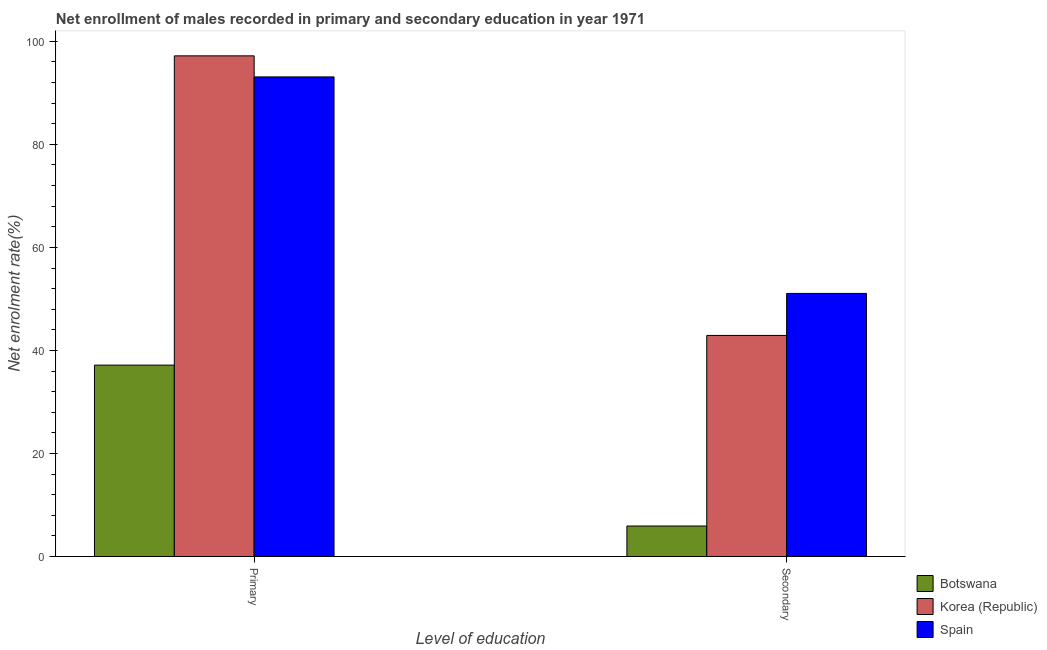How many different coloured bars are there?
Your answer should be compact. 3. How many groups of bars are there?
Your response must be concise. 2. Are the number of bars per tick equal to the number of legend labels?
Your answer should be very brief. Yes. Are the number of bars on each tick of the X-axis equal?
Keep it short and to the point. Yes. How many bars are there on the 1st tick from the left?
Your response must be concise. 3. What is the label of the 1st group of bars from the left?
Your response must be concise. Primary. What is the enrollment rate in primary education in Korea (Republic)?
Keep it short and to the point. 97.18. Across all countries, what is the maximum enrollment rate in primary education?
Your answer should be compact. 97.18. Across all countries, what is the minimum enrollment rate in primary education?
Your answer should be very brief. 37.15. In which country was the enrollment rate in primary education minimum?
Your response must be concise. Botswana. What is the total enrollment rate in secondary education in the graph?
Keep it short and to the point. 99.9. What is the difference between the enrollment rate in primary education in Spain and that in Botswana?
Offer a very short reply. 55.94. What is the difference between the enrollment rate in secondary education in Spain and the enrollment rate in primary education in Korea (Republic)?
Ensure brevity in your answer.  -46.11. What is the average enrollment rate in secondary education per country?
Your answer should be compact. 33.3. What is the difference between the enrollment rate in secondary education and enrollment rate in primary education in Korea (Republic)?
Ensure brevity in your answer.  -54.26. In how many countries, is the enrollment rate in primary education greater than 80 %?
Ensure brevity in your answer.  2. What is the ratio of the enrollment rate in primary education in Spain to that in Korea (Republic)?
Provide a succinct answer. 0.96. Is the enrollment rate in secondary education in Spain less than that in Korea (Republic)?
Make the answer very short. No. What does the 1st bar from the left in Primary represents?
Give a very brief answer. Botswana. What does the 3rd bar from the right in Primary represents?
Ensure brevity in your answer.  Botswana. Are all the bars in the graph horizontal?
Make the answer very short. No. Does the graph contain any zero values?
Offer a very short reply. No. Does the graph contain grids?
Provide a succinct answer. No. Where does the legend appear in the graph?
Ensure brevity in your answer.  Bottom right. How many legend labels are there?
Ensure brevity in your answer.  3. What is the title of the graph?
Give a very brief answer. Net enrollment of males recorded in primary and secondary education in year 1971. Does "St. Kitts and Nevis" appear as one of the legend labels in the graph?
Offer a very short reply. No. What is the label or title of the X-axis?
Offer a terse response. Level of education. What is the label or title of the Y-axis?
Provide a short and direct response. Net enrolment rate(%). What is the Net enrolment rate(%) of Botswana in Primary?
Keep it short and to the point. 37.15. What is the Net enrolment rate(%) in Korea (Republic) in Primary?
Keep it short and to the point. 97.18. What is the Net enrolment rate(%) of Spain in Primary?
Your response must be concise. 93.09. What is the Net enrolment rate(%) in Botswana in Secondary?
Ensure brevity in your answer.  5.92. What is the Net enrolment rate(%) in Korea (Republic) in Secondary?
Ensure brevity in your answer.  42.91. What is the Net enrolment rate(%) of Spain in Secondary?
Your response must be concise. 51.06. Across all Level of education, what is the maximum Net enrolment rate(%) in Botswana?
Provide a short and direct response. 37.15. Across all Level of education, what is the maximum Net enrolment rate(%) of Korea (Republic)?
Provide a succinct answer. 97.18. Across all Level of education, what is the maximum Net enrolment rate(%) in Spain?
Your response must be concise. 93.09. Across all Level of education, what is the minimum Net enrolment rate(%) in Botswana?
Your answer should be very brief. 5.92. Across all Level of education, what is the minimum Net enrolment rate(%) in Korea (Republic)?
Your answer should be compact. 42.91. Across all Level of education, what is the minimum Net enrolment rate(%) of Spain?
Provide a succinct answer. 51.06. What is the total Net enrolment rate(%) in Botswana in the graph?
Your answer should be very brief. 43.07. What is the total Net enrolment rate(%) of Korea (Republic) in the graph?
Make the answer very short. 140.09. What is the total Net enrolment rate(%) of Spain in the graph?
Ensure brevity in your answer.  144.15. What is the difference between the Net enrolment rate(%) in Botswana in Primary and that in Secondary?
Your response must be concise. 31.23. What is the difference between the Net enrolment rate(%) of Korea (Republic) in Primary and that in Secondary?
Provide a succinct answer. 54.26. What is the difference between the Net enrolment rate(%) of Spain in Primary and that in Secondary?
Ensure brevity in your answer.  42.02. What is the difference between the Net enrolment rate(%) in Botswana in Primary and the Net enrolment rate(%) in Korea (Republic) in Secondary?
Offer a very short reply. -5.76. What is the difference between the Net enrolment rate(%) in Botswana in Primary and the Net enrolment rate(%) in Spain in Secondary?
Ensure brevity in your answer.  -13.91. What is the difference between the Net enrolment rate(%) of Korea (Republic) in Primary and the Net enrolment rate(%) of Spain in Secondary?
Your answer should be very brief. 46.11. What is the average Net enrolment rate(%) in Botswana per Level of education?
Your answer should be compact. 21.54. What is the average Net enrolment rate(%) of Korea (Republic) per Level of education?
Your answer should be very brief. 70.04. What is the average Net enrolment rate(%) in Spain per Level of education?
Your answer should be very brief. 72.08. What is the difference between the Net enrolment rate(%) in Botswana and Net enrolment rate(%) in Korea (Republic) in Primary?
Your answer should be very brief. -60.02. What is the difference between the Net enrolment rate(%) of Botswana and Net enrolment rate(%) of Spain in Primary?
Your answer should be very brief. -55.94. What is the difference between the Net enrolment rate(%) in Korea (Republic) and Net enrolment rate(%) in Spain in Primary?
Ensure brevity in your answer.  4.09. What is the difference between the Net enrolment rate(%) in Botswana and Net enrolment rate(%) in Korea (Republic) in Secondary?
Provide a short and direct response. -36.99. What is the difference between the Net enrolment rate(%) of Botswana and Net enrolment rate(%) of Spain in Secondary?
Your answer should be very brief. -45.14. What is the difference between the Net enrolment rate(%) in Korea (Republic) and Net enrolment rate(%) in Spain in Secondary?
Give a very brief answer. -8.15. What is the ratio of the Net enrolment rate(%) in Botswana in Primary to that in Secondary?
Your answer should be very brief. 6.27. What is the ratio of the Net enrolment rate(%) in Korea (Republic) in Primary to that in Secondary?
Your answer should be very brief. 2.26. What is the ratio of the Net enrolment rate(%) of Spain in Primary to that in Secondary?
Offer a terse response. 1.82. What is the difference between the highest and the second highest Net enrolment rate(%) of Botswana?
Your answer should be compact. 31.23. What is the difference between the highest and the second highest Net enrolment rate(%) of Korea (Republic)?
Make the answer very short. 54.26. What is the difference between the highest and the second highest Net enrolment rate(%) of Spain?
Ensure brevity in your answer.  42.02. What is the difference between the highest and the lowest Net enrolment rate(%) in Botswana?
Your answer should be very brief. 31.23. What is the difference between the highest and the lowest Net enrolment rate(%) of Korea (Republic)?
Provide a succinct answer. 54.26. What is the difference between the highest and the lowest Net enrolment rate(%) of Spain?
Make the answer very short. 42.02. 